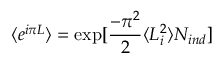Convert formula to latex. <formula><loc_0><loc_0><loc_500><loc_500>\langle e ^ { i \pi L } \rangle = \exp [ \frac { - \pi ^ { 2 } } { 2 } \langle L _ { i } ^ { 2 } \rangle N _ { i n d } ]</formula> 